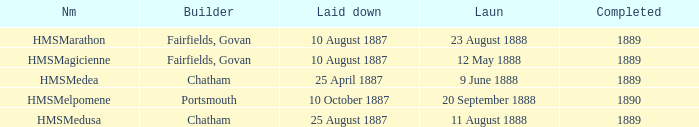When was the completion of the hms medusa by chatham? 1889.0. 